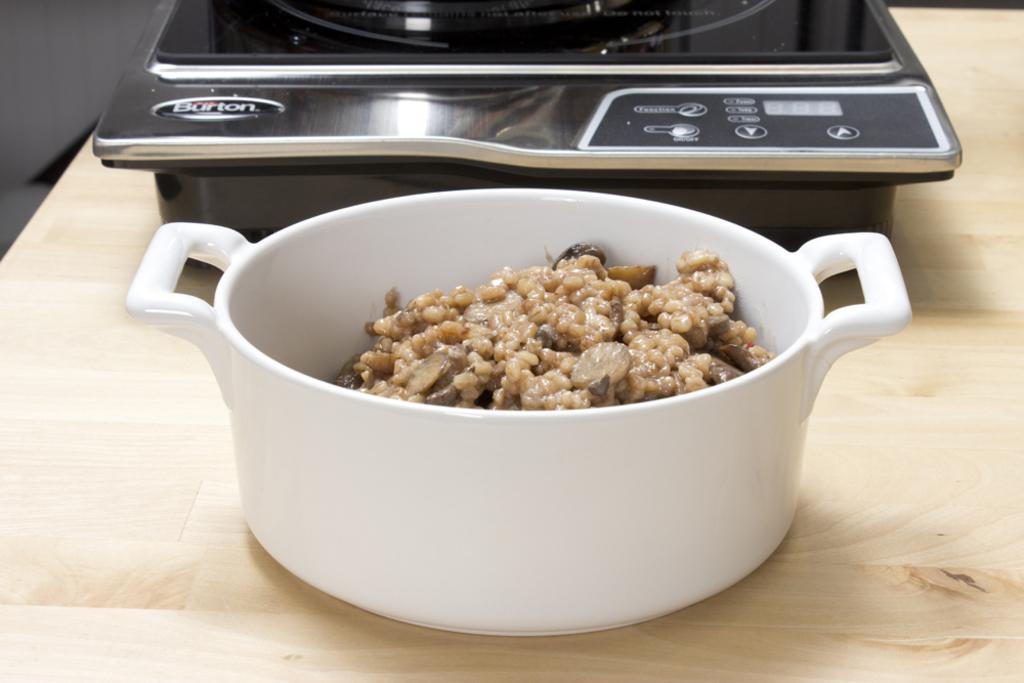<image>
Summarize the visual content of the image. The equipment behind the meal is made by a company called Burton. 